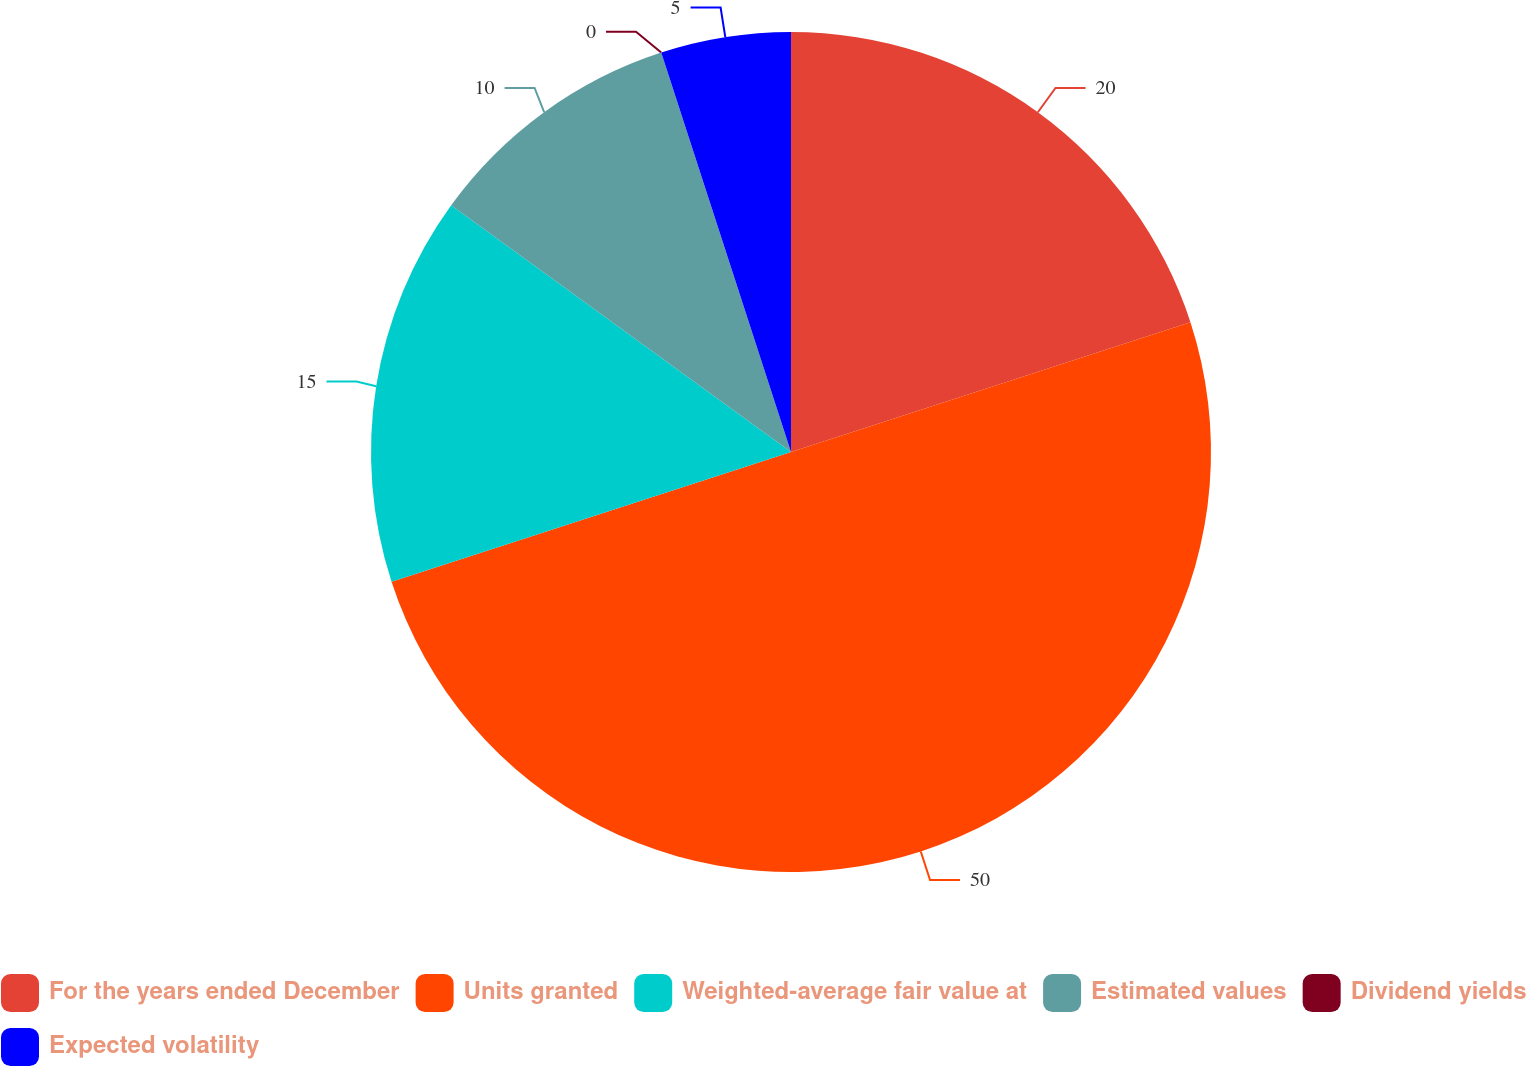<chart> <loc_0><loc_0><loc_500><loc_500><pie_chart><fcel>For the years ended December<fcel>Units granted<fcel>Weighted-average fair value at<fcel>Estimated values<fcel>Dividend yields<fcel>Expected volatility<nl><fcel>20.0%<fcel>50.0%<fcel>15.0%<fcel>10.0%<fcel>0.0%<fcel>5.0%<nl></chart> 